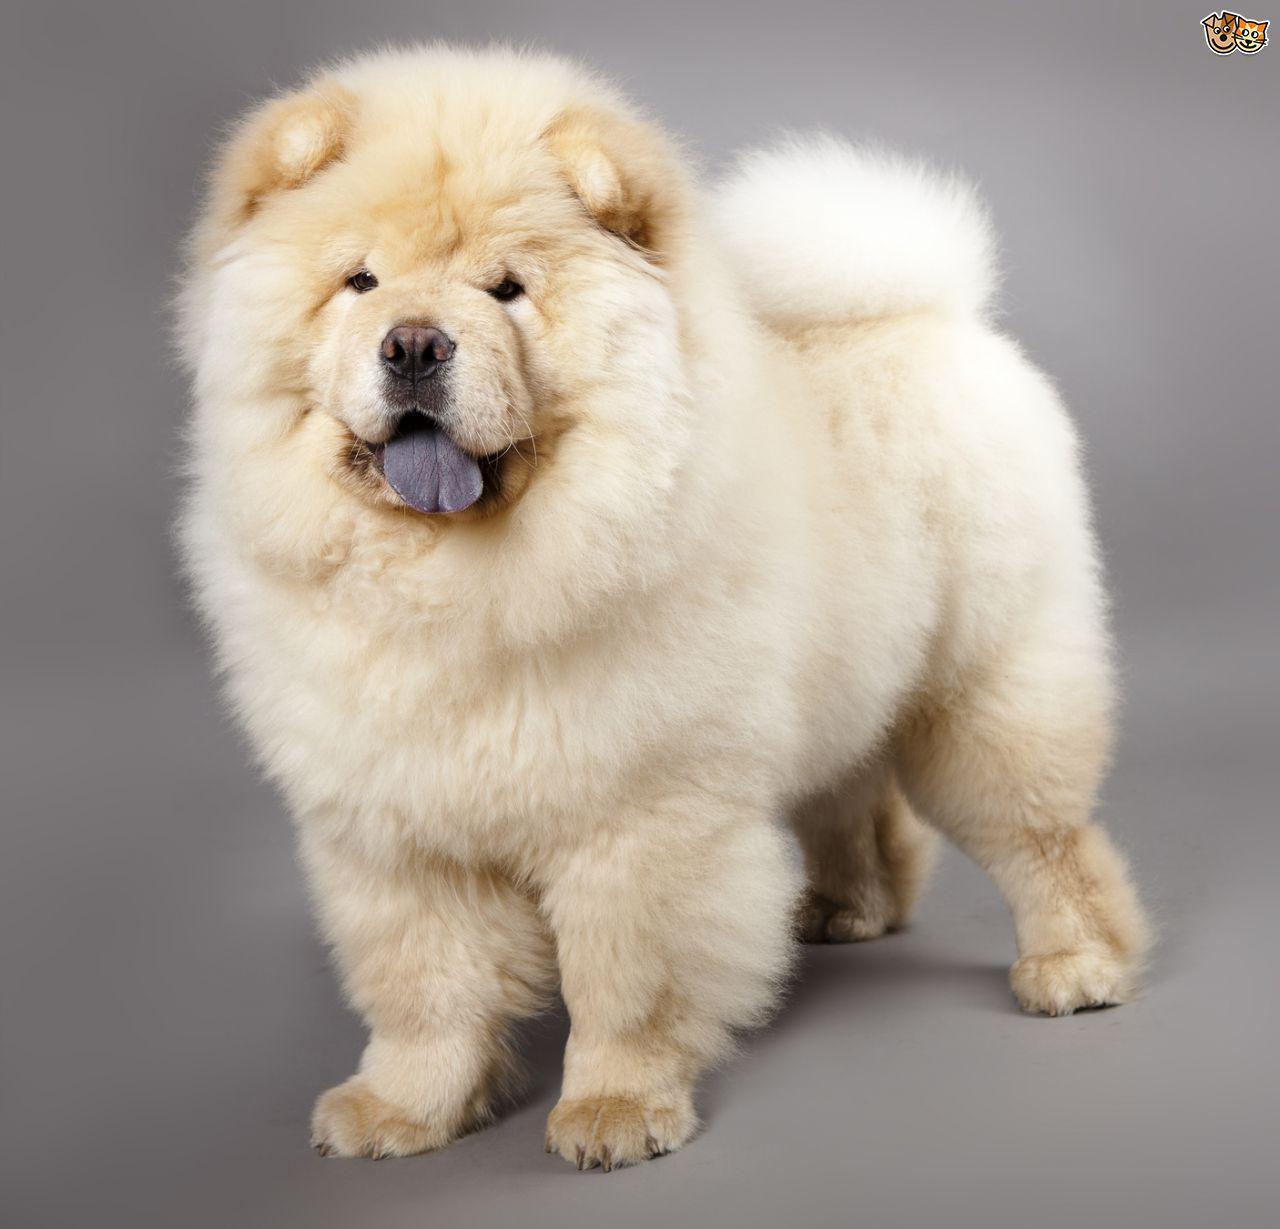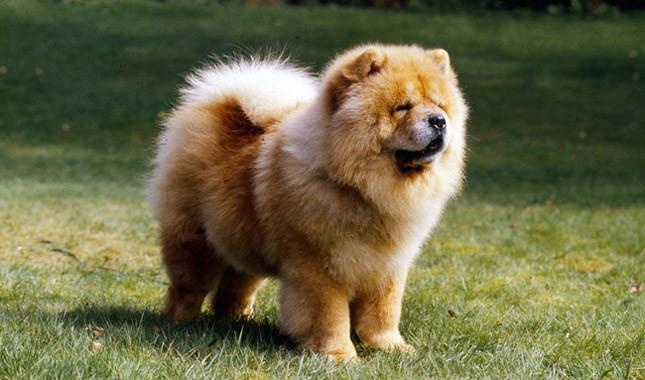The first image is the image on the left, the second image is the image on the right. Assess this claim about the two images: "The dog in the left image is orange and faces rightward.". Correct or not? Answer yes or no. No. 